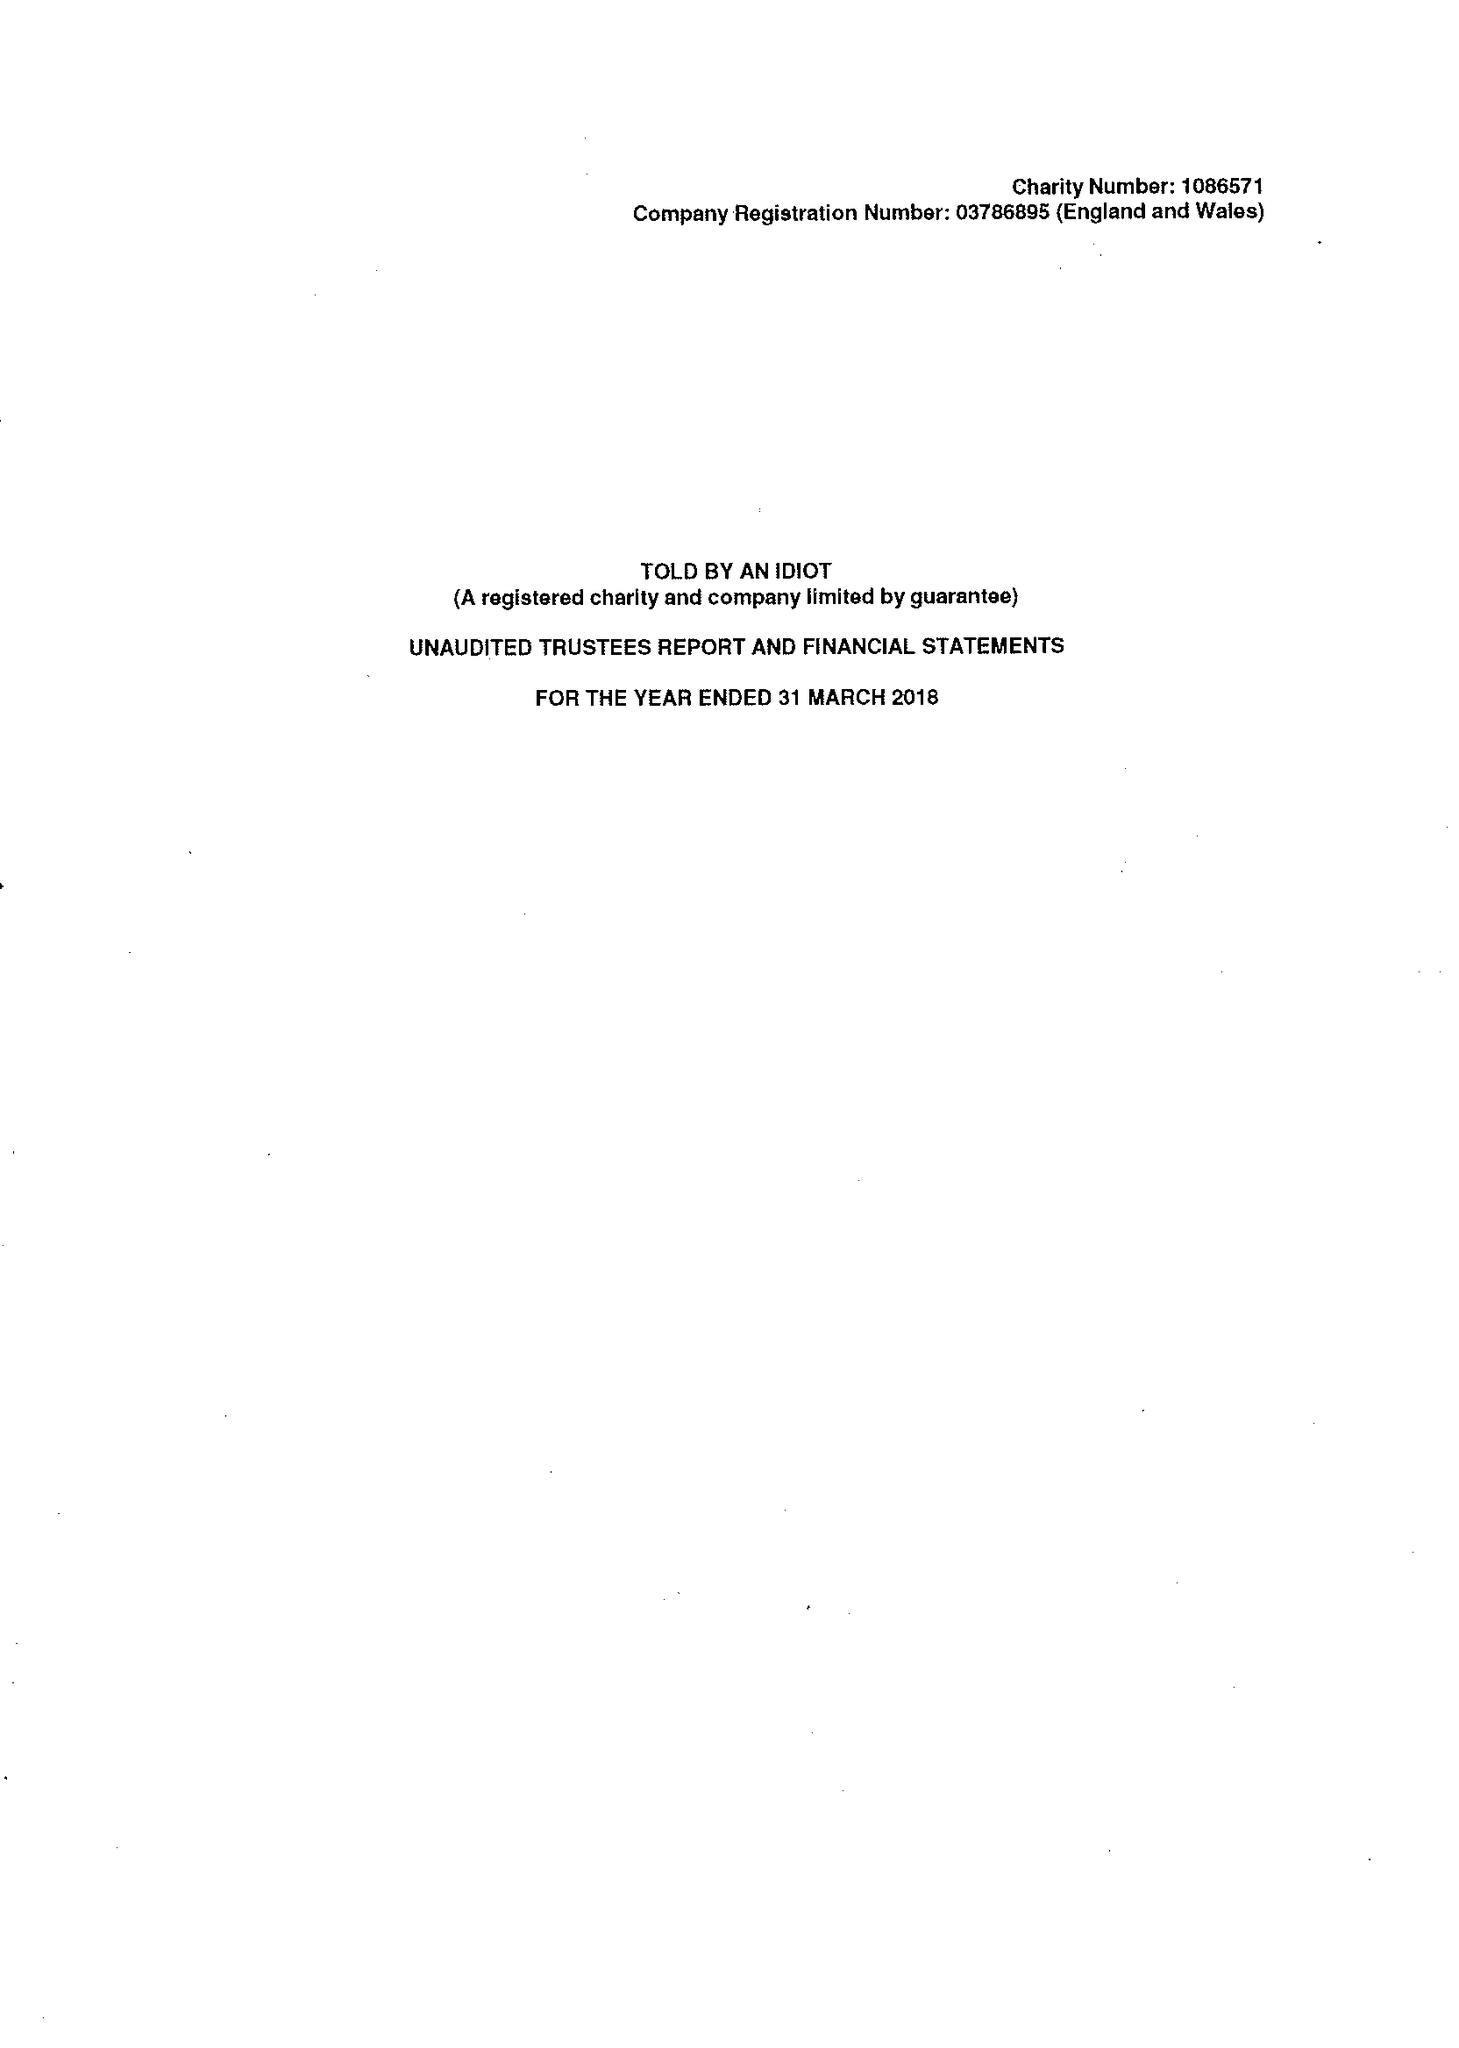What is the value for the spending_annually_in_british_pounds?
Answer the question using a single word or phrase. 331158.00 